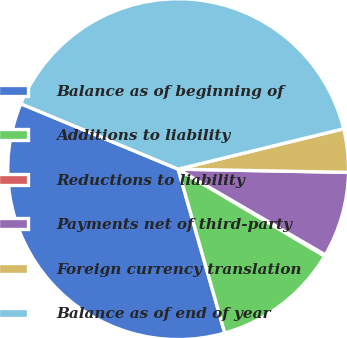Convert chart. <chart><loc_0><loc_0><loc_500><loc_500><pie_chart><fcel>Balance as of beginning of<fcel>Additions to liability<fcel>Reductions to liability<fcel>Payments net of third-party<fcel>Foreign currency translation<fcel>Balance as of end of year<nl><fcel>35.68%<fcel>12.07%<fcel>0.13%<fcel>8.09%<fcel>4.11%<fcel>39.92%<nl></chart> 